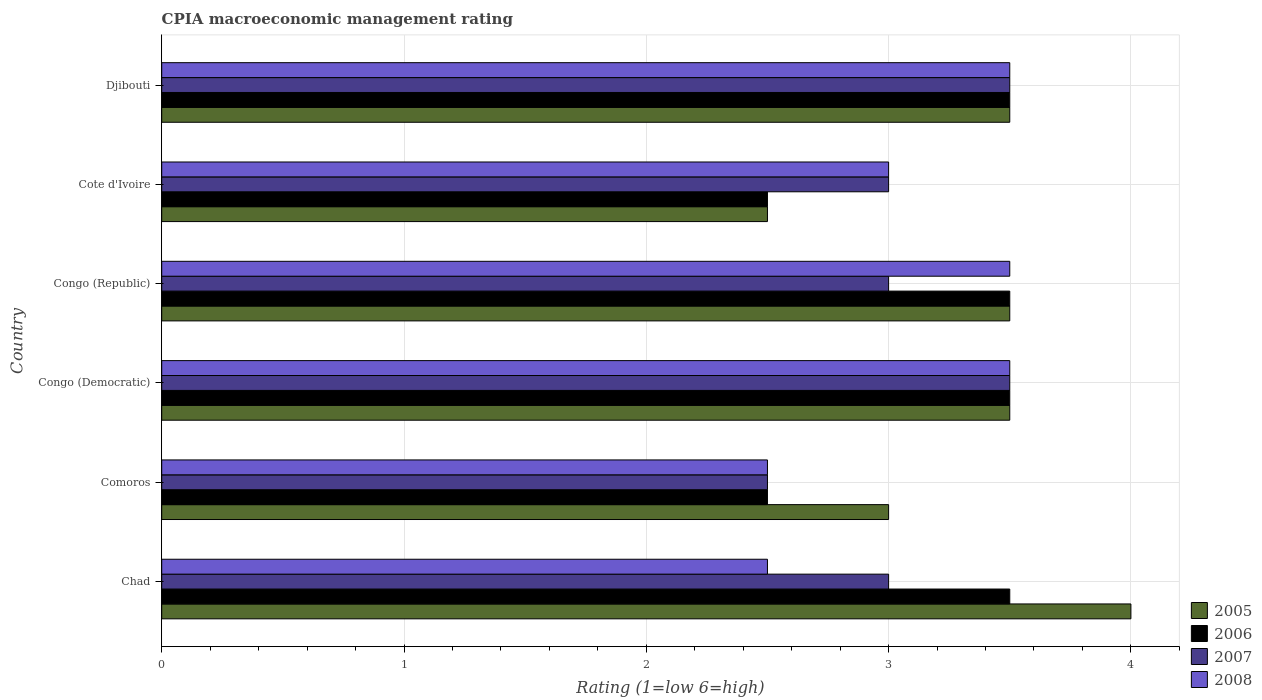How many different coloured bars are there?
Your response must be concise. 4. Are the number of bars per tick equal to the number of legend labels?
Keep it short and to the point. Yes. Are the number of bars on each tick of the Y-axis equal?
Provide a short and direct response. Yes. How many bars are there on the 2nd tick from the bottom?
Ensure brevity in your answer.  4. What is the label of the 5th group of bars from the top?
Give a very brief answer. Comoros. Across all countries, what is the maximum CPIA rating in 2006?
Make the answer very short. 3.5. Across all countries, what is the minimum CPIA rating in 2008?
Your answer should be very brief. 2.5. In which country was the CPIA rating in 2008 maximum?
Your response must be concise. Congo (Democratic). In which country was the CPIA rating in 2006 minimum?
Offer a terse response. Comoros. What is the total CPIA rating in 2007 in the graph?
Provide a succinct answer. 18.5. What is the difference between the CPIA rating in 2007 in Comoros and that in Congo (Republic)?
Offer a very short reply. -0.5. What is the average CPIA rating in 2005 per country?
Your answer should be very brief. 3.33. What is the difference between the CPIA rating in 2007 and CPIA rating in 2006 in Congo (Democratic)?
Make the answer very short. 0. In how many countries, is the CPIA rating in 2006 greater than 2.8 ?
Provide a short and direct response. 4. What is the ratio of the CPIA rating in 2008 in Chad to that in Congo (Democratic)?
Make the answer very short. 0.71. Is the difference between the CPIA rating in 2007 in Comoros and Congo (Republic) greater than the difference between the CPIA rating in 2006 in Comoros and Congo (Republic)?
Offer a terse response. Yes. What is the difference between the highest and the second highest CPIA rating in 2006?
Your response must be concise. 0. In how many countries, is the CPIA rating in 2006 greater than the average CPIA rating in 2006 taken over all countries?
Your answer should be compact. 4. Is the sum of the CPIA rating in 2007 in Congo (Democratic) and Congo (Republic) greater than the maximum CPIA rating in 2005 across all countries?
Make the answer very short. Yes. What does the 2nd bar from the top in Djibouti represents?
Your answer should be compact. 2007. What does the 2nd bar from the bottom in Djibouti represents?
Provide a succinct answer. 2006. How many bars are there?
Your answer should be very brief. 24. Are all the bars in the graph horizontal?
Provide a succinct answer. Yes. How many countries are there in the graph?
Keep it short and to the point. 6. Are the values on the major ticks of X-axis written in scientific E-notation?
Your response must be concise. No. Does the graph contain any zero values?
Offer a terse response. No. Does the graph contain grids?
Give a very brief answer. Yes. Where does the legend appear in the graph?
Give a very brief answer. Bottom right. How are the legend labels stacked?
Keep it short and to the point. Vertical. What is the title of the graph?
Provide a short and direct response. CPIA macroeconomic management rating. Does "2010" appear as one of the legend labels in the graph?
Your response must be concise. No. What is the label or title of the X-axis?
Offer a very short reply. Rating (1=low 6=high). What is the Rating (1=low 6=high) in 2005 in Chad?
Make the answer very short. 4. What is the Rating (1=low 6=high) of 2006 in Chad?
Give a very brief answer. 3.5. What is the Rating (1=low 6=high) in 2007 in Chad?
Keep it short and to the point. 3. What is the Rating (1=low 6=high) in 2005 in Comoros?
Give a very brief answer. 3. What is the Rating (1=low 6=high) in 2006 in Comoros?
Provide a short and direct response. 2.5. What is the Rating (1=low 6=high) of 2008 in Comoros?
Keep it short and to the point. 2.5. What is the Rating (1=low 6=high) of 2005 in Congo (Democratic)?
Provide a short and direct response. 3.5. What is the Rating (1=low 6=high) in 2006 in Congo (Democratic)?
Ensure brevity in your answer.  3.5. What is the Rating (1=low 6=high) of 2007 in Congo (Democratic)?
Offer a very short reply. 3.5. What is the Rating (1=low 6=high) of 2008 in Congo (Democratic)?
Your response must be concise. 3.5. What is the Rating (1=low 6=high) of 2008 in Congo (Republic)?
Provide a succinct answer. 3.5. What is the Rating (1=low 6=high) in 2006 in Cote d'Ivoire?
Your answer should be compact. 2.5. What is the Rating (1=low 6=high) of 2008 in Cote d'Ivoire?
Your response must be concise. 3. What is the Rating (1=low 6=high) of 2005 in Djibouti?
Keep it short and to the point. 3.5. What is the Rating (1=low 6=high) of 2006 in Djibouti?
Offer a terse response. 3.5. Across all countries, what is the maximum Rating (1=low 6=high) of 2005?
Make the answer very short. 4. Across all countries, what is the maximum Rating (1=low 6=high) in 2007?
Keep it short and to the point. 3.5. Across all countries, what is the maximum Rating (1=low 6=high) in 2008?
Your response must be concise. 3.5. Across all countries, what is the minimum Rating (1=low 6=high) in 2006?
Your answer should be very brief. 2.5. Across all countries, what is the minimum Rating (1=low 6=high) of 2007?
Your answer should be compact. 2.5. What is the total Rating (1=low 6=high) of 2006 in the graph?
Ensure brevity in your answer.  19. What is the total Rating (1=low 6=high) of 2007 in the graph?
Offer a very short reply. 18.5. What is the difference between the Rating (1=low 6=high) of 2007 in Chad and that in Comoros?
Provide a succinct answer. 0.5. What is the difference between the Rating (1=low 6=high) in 2008 in Chad and that in Comoros?
Offer a very short reply. 0. What is the difference between the Rating (1=low 6=high) in 2007 in Chad and that in Congo (Democratic)?
Your answer should be compact. -0.5. What is the difference between the Rating (1=low 6=high) in 2008 in Chad and that in Congo (Democratic)?
Make the answer very short. -1. What is the difference between the Rating (1=low 6=high) in 2005 in Chad and that in Cote d'Ivoire?
Your answer should be compact. 1.5. What is the difference between the Rating (1=low 6=high) in 2006 in Chad and that in Cote d'Ivoire?
Provide a succinct answer. 1. What is the difference between the Rating (1=low 6=high) in 2006 in Chad and that in Djibouti?
Your answer should be very brief. 0. What is the difference between the Rating (1=low 6=high) of 2006 in Comoros and that in Congo (Democratic)?
Offer a very short reply. -1. What is the difference between the Rating (1=low 6=high) in 2005 in Comoros and that in Congo (Republic)?
Your response must be concise. -0.5. What is the difference between the Rating (1=low 6=high) of 2007 in Comoros and that in Congo (Republic)?
Your response must be concise. -0.5. What is the difference between the Rating (1=low 6=high) in 2005 in Comoros and that in Cote d'Ivoire?
Keep it short and to the point. 0.5. What is the difference between the Rating (1=low 6=high) in 2006 in Comoros and that in Cote d'Ivoire?
Provide a short and direct response. 0. What is the difference between the Rating (1=low 6=high) in 2007 in Comoros and that in Cote d'Ivoire?
Make the answer very short. -0.5. What is the difference between the Rating (1=low 6=high) in 2008 in Comoros and that in Cote d'Ivoire?
Ensure brevity in your answer.  -0.5. What is the difference between the Rating (1=low 6=high) of 2006 in Comoros and that in Djibouti?
Keep it short and to the point. -1. What is the difference between the Rating (1=low 6=high) of 2007 in Comoros and that in Djibouti?
Your response must be concise. -1. What is the difference between the Rating (1=low 6=high) in 2005 in Congo (Democratic) and that in Congo (Republic)?
Provide a short and direct response. 0. What is the difference between the Rating (1=low 6=high) in 2007 in Congo (Democratic) and that in Congo (Republic)?
Your answer should be compact. 0.5. What is the difference between the Rating (1=low 6=high) in 2008 in Congo (Democratic) and that in Congo (Republic)?
Your response must be concise. 0. What is the difference between the Rating (1=low 6=high) in 2008 in Congo (Democratic) and that in Djibouti?
Make the answer very short. 0. What is the difference between the Rating (1=low 6=high) of 2007 in Congo (Republic) and that in Cote d'Ivoire?
Offer a very short reply. 0. What is the difference between the Rating (1=low 6=high) of 2005 in Congo (Republic) and that in Djibouti?
Provide a succinct answer. 0. What is the difference between the Rating (1=low 6=high) of 2006 in Cote d'Ivoire and that in Djibouti?
Provide a short and direct response. -1. What is the difference between the Rating (1=low 6=high) in 2007 in Cote d'Ivoire and that in Djibouti?
Provide a succinct answer. -0.5. What is the difference between the Rating (1=low 6=high) in 2008 in Cote d'Ivoire and that in Djibouti?
Offer a very short reply. -0.5. What is the difference between the Rating (1=low 6=high) in 2005 in Chad and the Rating (1=low 6=high) in 2008 in Comoros?
Offer a very short reply. 1.5. What is the difference between the Rating (1=low 6=high) in 2007 in Chad and the Rating (1=low 6=high) in 2008 in Comoros?
Your response must be concise. 0.5. What is the difference between the Rating (1=low 6=high) in 2005 in Chad and the Rating (1=low 6=high) in 2007 in Congo (Democratic)?
Your response must be concise. 0.5. What is the difference between the Rating (1=low 6=high) in 2005 in Chad and the Rating (1=low 6=high) in 2008 in Congo (Democratic)?
Keep it short and to the point. 0.5. What is the difference between the Rating (1=low 6=high) in 2005 in Chad and the Rating (1=low 6=high) in 2006 in Congo (Republic)?
Ensure brevity in your answer.  0.5. What is the difference between the Rating (1=low 6=high) in 2005 in Chad and the Rating (1=low 6=high) in 2007 in Congo (Republic)?
Your answer should be compact. 1. What is the difference between the Rating (1=low 6=high) of 2005 in Chad and the Rating (1=low 6=high) of 2008 in Congo (Republic)?
Provide a succinct answer. 0.5. What is the difference between the Rating (1=low 6=high) in 2006 in Chad and the Rating (1=low 6=high) in 2008 in Congo (Republic)?
Make the answer very short. 0. What is the difference between the Rating (1=low 6=high) in 2007 in Chad and the Rating (1=low 6=high) in 2008 in Congo (Republic)?
Keep it short and to the point. -0.5. What is the difference between the Rating (1=low 6=high) in 2005 in Chad and the Rating (1=low 6=high) in 2006 in Cote d'Ivoire?
Make the answer very short. 1.5. What is the difference between the Rating (1=low 6=high) of 2006 in Chad and the Rating (1=low 6=high) of 2008 in Cote d'Ivoire?
Give a very brief answer. 0.5. What is the difference between the Rating (1=low 6=high) of 2007 in Chad and the Rating (1=low 6=high) of 2008 in Cote d'Ivoire?
Offer a very short reply. 0. What is the difference between the Rating (1=low 6=high) in 2005 in Chad and the Rating (1=low 6=high) in 2006 in Djibouti?
Your answer should be compact. 0.5. What is the difference between the Rating (1=low 6=high) of 2005 in Chad and the Rating (1=low 6=high) of 2007 in Djibouti?
Your answer should be very brief. 0.5. What is the difference between the Rating (1=low 6=high) of 2005 in Chad and the Rating (1=low 6=high) of 2008 in Djibouti?
Keep it short and to the point. 0.5. What is the difference between the Rating (1=low 6=high) of 2005 in Comoros and the Rating (1=low 6=high) of 2007 in Congo (Democratic)?
Provide a short and direct response. -0.5. What is the difference between the Rating (1=low 6=high) in 2005 in Comoros and the Rating (1=low 6=high) in 2008 in Congo (Democratic)?
Keep it short and to the point. -0.5. What is the difference between the Rating (1=low 6=high) of 2005 in Comoros and the Rating (1=low 6=high) of 2006 in Congo (Republic)?
Your answer should be very brief. -0.5. What is the difference between the Rating (1=low 6=high) of 2005 in Comoros and the Rating (1=low 6=high) of 2008 in Congo (Republic)?
Offer a very short reply. -0.5. What is the difference between the Rating (1=low 6=high) of 2006 in Comoros and the Rating (1=low 6=high) of 2007 in Congo (Republic)?
Your answer should be very brief. -0.5. What is the difference between the Rating (1=low 6=high) of 2006 in Comoros and the Rating (1=low 6=high) of 2008 in Congo (Republic)?
Your response must be concise. -1. What is the difference between the Rating (1=low 6=high) in 2005 in Comoros and the Rating (1=low 6=high) in 2006 in Cote d'Ivoire?
Provide a succinct answer. 0.5. What is the difference between the Rating (1=low 6=high) in 2006 in Comoros and the Rating (1=low 6=high) in 2007 in Cote d'Ivoire?
Provide a succinct answer. -0.5. What is the difference between the Rating (1=low 6=high) of 2005 in Comoros and the Rating (1=low 6=high) of 2006 in Djibouti?
Offer a terse response. -0.5. What is the difference between the Rating (1=low 6=high) in 2005 in Comoros and the Rating (1=low 6=high) in 2008 in Djibouti?
Give a very brief answer. -0.5. What is the difference between the Rating (1=low 6=high) in 2006 in Comoros and the Rating (1=low 6=high) in 2008 in Djibouti?
Offer a very short reply. -1. What is the difference between the Rating (1=low 6=high) in 2005 in Congo (Democratic) and the Rating (1=low 6=high) in 2006 in Congo (Republic)?
Give a very brief answer. 0. What is the difference between the Rating (1=low 6=high) of 2005 in Congo (Democratic) and the Rating (1=low 6=high) of 2007 in Congo (Republic)?
Your answer should be very brief. 0.5. What is the difference between the Rating (1=low 6=high) of 2005 in Congo (Democratic) and the Rating (1=low 6=high) of 2008 in Congo (Republic)?
Your answer should be compact. 0. What is the difference between the Rating (1=low 6=high) of 2005 in Congo (Democratic) and the Rating (1=low 6=high) of 2006 in Cote d'Ivoire?
Your response must be concise. 1. What is the difference between the Rating (1=low 6=high) of 2005 in Congo (Democratic) and the Rating (1=low 6=high) of 2008 in Cote d'Ivoire?
Your response must be concise. 0.5. What is the difference between the Rating (1=low 6=high) of 2006 in Congo (Democratic) and the Rating (1=low 6=high) of 2007 in Cote d'Ivoire?
Your answer should be compact. 0.5. What is the difference between the Rating (1=low 6=high) of 2006 in Congo (Democratic) and the Rating (1=low 6=high) of 2008 in Cote d'Ivoire?
Offer a very short reply. 0.5. What is the difference between the Rating (1=low 6=high) of 2007 in Congo (Democratic) and the Rating (1=low 6=high) of 2008 in Cote d'Ivoire?
Ensure brevity in your answer.  0.5. What is the difference between the Rating (1=low 6=high) of 2005 in Congo (Democratic) and the Rating (1=low 6=high) of 2007 in Djibouti?
Your answer should be very brief. 0. What is the difference between the Rating (1=low 6=high) in 2005 in Congo (Democratic) and the Rating (1=low 6=high) in 2008 in Djibouti?
Ensure brevity in your answer.  0. What is the difference between the Rating (1=low 6=high) of 2006 in Congo (Democratic) and the Rating (1=low 6=high) of 2007 in Djibouti?
Offer a very short reply. 0. What is the difference between the Rating (1=low 6=high) of 2006 in Congo (Democratic) and the Rating (1=low 6=high) of 2008 in Djibouti?
Make the answer very short. 0. What is the difference between the Rating (1=low 6=high) in 2006 in Congo (Republic) and the Rating (1=low 6=high) in 2007 in Cote d'Ivoire?
Ensure brevity in your answer.  0.5. What is the difference between the Rating (1=low 6=high) in 2005 in Congo (Republic) and the Rating (1=low 6=high) in 2006 in Djibouti?
Your answer should be compact. 0. What is the difference between the Rating (1=low 6=high) of 2006 in Congo (Republic) and the Rating (1=low 6=high) of 2007 in Djibouti?
Provide a succinct answer. 0. What is the difference between the Rating (1=low 6=high) of 2006 in Congo (Republic) and the Rating (1=low 6=high) of 2008 in Djibouti?
Make the answer very short. 0. What is the difference between the Rating (1=low 6=high) of 2007 in Congo (Republic) and the Rating (1=low 6=high) of 2008 in Djibouti?
Your response must be concise. -0.5. What is the difference between the Rating (1=low 6=high) in 2005 in Cote d'Ivoire and the Rating (1=low 6=high) in 2007 in Djibouti?
Keep it short and to the point. -1. What is the average Rating (1=low 6=high) of 2005 per country?
Provide a short and direct response. 3.33. What is the average Rating (1=low 6=high) in 2006 per country?
Give a very brief answer. 3.17. What is the average Rating (1=low 6=high) of 2007 per country?
Offer a very short reply. 3.08. What is the average Rating (1=low 6=high) of 2008 per country?
Keep it short and to the point. 3.08. What is the difference between the Rating (1=low 6=high) of 2006 and Rating (1=low 6=high) of 2007 in Chad?
Offer a terse response. 0.5. What is the difference between the Rating (1=low 6=high) of 2006 and Rating (1=low 6=high) of 2008 in Chad?
Keep it short and to the point. 1. What is the difference between the Rating (1=low 6=high) of 2007 and Rating (1=low 6=high) of 2008 in Chad?
Make the answer very short. 0.5. What is the difference between the Rating (1=low 6=high) in 2005 and Rating (1=low 6=high) in 2006 in Comoros?
Make the answer very short. 0.5. What is the difference between the Rating (1=low 6=high) in 2006 and Rating (1=low 6=high) in 2007 in Comoros?
Your answer should be very brief. 0. What is the difference between the Rating (1=low 6=high) in 2007 and Rating (1=low 6=high) in 2008 in Comoros?
Give a very brief answer. 0. What is the difference between the Rating (1=low 6=high) of 2005 and Rating (1=low 6=high) of 2007 in Congo (Democratic)?
Your answer should be compact. 0. What is the difference between the Rating (1=low 6=high) in 2005 and Rating (1=low 6=high) in 2008 in Congo (Democratic)?
Give a very brief answer. 0. What is the difference between the Rating (1=low 6=high) in 2006 and Rating (1=low 6=high) in 2007 in Congo (Democratic)?
Your answer should be very brief. 0. What is the difference between the Rating (1=low 6=high) in 2006 and Rating (1=low 6=high) in 2008 in Congo (Democratic)?
Make the answer very short. 0. What is the difference between the Rating (1=low 6=high) in 2005 and Rating (1=low 6=high) in 2006 in Congo (Republic)?
Make the answer very short. 0. What is the difference between the Rating (1=low 6=high) of 2005 and Rating (1=low 6=high) of 2007 in Congo (Republic)?
Provide a short and direct response. 0.5. What is the difference between the Rating (1=low 6=high) in 2006 and Rating (1=low 6=high) in 2007 in Congo (Republic)?
Provide a short and direct response. 0.5. What is the difference between the Rating (1=low 6=high) of 2007 and Rating (1=low 6=high) of 2008 in Congo (Republic)?
Your response must be concise. -0.5. What is the difference between the Rating (1=low 6=high) of 2005 and Rating (1=low 6=high) of 2006 in Cote d'Ivoire?
Offer a terse response. 0. What is the difference between the Rating (1=low 6=high) of 2005 and Rating (1=low 6=high) of 2007 in Cote d'Ivoire?
Offer a very short reply. -0.5. What is the difference between the Rating (1=low 6=high) in 2007 and Rating (1=low 6=high) in 2008 in Cote d'Ivoire?
Keep it short and to the point. 0. What is the difference between the Rating (1=low 6=high) of 2005 and Rating (1=low 6=high) of 2006 in Djibouti?
Provide a succinct answer. 0. What is the difference between the Rating (1=low 6=high) of 2005 and Rating (1=low 6=high) of 2008 in Djibouti?
Give a very brief answer. 0. What is the ratio of the Rating (1=low 6=high) in 2005 in Chad to that in Comoros?
Your response must be concise. 1.33. What is the ratio of the Rating (1=low 6=high) in 2006 in Chad to that in Congo (Democratic)?
Keep it short and to the point. 1. What is the ratio of the Rating (1=low 6=high) of 2007 in Chad to that in Congo (Democratic)?
Make the answer very short. 0.86. What is the ratio of the Rating (1=low 6=high) of 2008 in Chad to that in Congo (Democratic)?
Provide a short and direct response. 0.71. What is the ratio of the Rating (1=low 6=high) of 2005 in Chad to that in Congo (Republic)?
Your answer should be compact. 1.14. What is the ratio of the Rating (1=low 6=high) of 2006 in Chad to that in Congo (Republic)?
Your answer should be compact. 1. What is the ratio of the Rating (1=low 6=high) in 2005 in Chad to that in Cote d'Ivoire?
Ensure brevity in your answer.  1.6. What is the ratio of the Rating (1=low 6=high) in 2007 in Chad to that in Cote d'Ivoire?
Make the answer very short. 1. What is the ratio of the Rating (1=low 6=high) of 2008 in Chad to that in Cote d'Ivoire?
Offer a very short reply. 0.83. What is the ratio of the Rating (1=low 6=high) of 2005 in Chad to that in Djibouti?
Your answer should be very brief. 1.14. What is the ratio of the Rating (1=low 6=high) of 2005 in Comoros to that in Congo (Democratic)?
Make the answer very short. 0.86. What is the ratio of the Rating (1=low 6=high) of 2006 in Comoros to that in Congo (Democratic)?
Provide a succinct answer. 0.71. What is the ratio of the Rating (1=low 6=high) in 2007 in Comoros to that in Congo (Democratic)?
Offer a very short reply. 0.71. What is the ratio of the Rating (1=low 6=high) of 2005 in Comoros to that in Congo (Republic)?
Offer a very short reply. 0.86. What is the ratio of the Rating (1=low 6=high) in 2006 in Comoros to that in Congo (Republic)?
Give a very brief answer. 0.71. What is the ratio of the Rating (1=low 6=high) of 2007 in Comoros to that in Congo (Republic)?
Give a very brief answer. 0.83. What is the ratio of the Rating (1=low 6=high) in 2005 in Comoros to that in Cote d'Ivoire?
Your response must be concise. 1.2. What is the ratio of the Rating (1=low 6=high) of 2008 in Comoros to that in Cote d'Ivoire?
Your answer should be very brief. 0.83. What is the ratio of the Rating (1=low 6=high) of 2005 in Comoros to that in Djibouti?
Ensure brevity in your answer.  0.86. What is the ratio of the Rating (1=low 6=high) of 2006 in Comoros to that in Djibouti?
Keep it short and to the point. 0.71. What is the ratio of the Rating (1=low 6=high) in 2006 in Congo (Democratic) to that in Congo (Republic)?
Provide a succinct answer. 1. What is the ratio of the Rating (1=low 6=high) in 2006 in Congo (Democratic) to that in Cote d'Ivoire?
Make the answer very short. 1.4. What is the ratio of the Rating (1=low 6=high) of 2007 in Congo (Democratic) to that in Cote d'Ivoire?
Make the answer very short. 1.17. What is the ratio of the Rating (1=low 6=high) of 2008 in Congo (Democratic) to that in Cote d'Ivoire?
Keep it short and to the point. 1.17. What is the ratio of the Rating (1=low 6=high) in 2005 in Congo (Democratic) to that in Djibouti?
Give a very brief answer. 1. What is the ratio of the Rating (1=low 6=high) of 2006 in Congo (Democratic) to that in Djibouti?
Offer a terse response. 1. What is the ratio of the Rating (1=low 6=high) of 2007 in Congo (Democratic) to that in Djibouti?
Ensure brevity in your answer.  1. What is the ratio of the Rating (1=low 6=high) in 2008 in Congo (Democratic) to that in Djibouti?
Your answer should be compact. 1. What is the ratio of the Rating (1=low 6=high) in 2005 in Congo (Republic) to that in Djibouti?
Offer a very short reply. 1. What is the ratio of the Rating (1=low 6=high) in 2005 in Cote d'Ivoire to that in Djibouti?
Your response must be concise. 0.71. What is the ratio of the Rating (1=low 6=high) of 2008 in Cote d'Ivoire to that in Djibouti?
Offer a very short reply. 0.86. What is the difference between the highest and the second highest Rating (1=low 6=high) in 2006?
Make the answer very short. 0. What is the difference between the highest and the lowest Rating (1=low 6=high) of 2005?
Your answer should be compact. 1.5. 